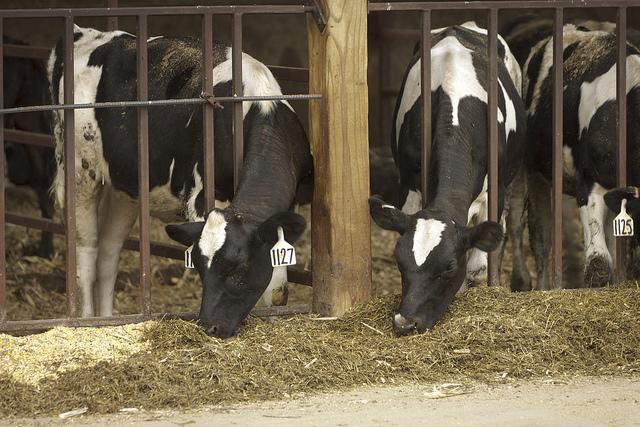If these cows could talk, what would they tell us about their experience living on this farm? If these cows could talk, they might tell us about their daily routines, the comfort of their indoor environment, and their interactions with the friendly farm staff. They would probably express their gratitude for the care and attention they receive but might also share their curious thoughts about the outside world beyond the barn. 